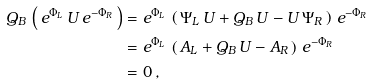<formula> <loc_0><loc_0><loc_500><loc_500>Q _ { B } \, \left ( \, e ^ { \Phi _ { L } } \, U \, e ^ { - \Phi _ { R } } \, \right ) & = e ^ { \Phi _ { L } } \, \left ( \, \Psi _ { L } \, U + Q _ { B } \, U - U \, \Psi _ { R } \, \right ) \, e ^ { - \Phi _ { R } } \\ & = e ^ { \Phi _ { L } } \, \left ( \, A _ { L } + Q _ { B } \, U - A _ { R } \, \right ) \, e ^ { - \Phi _ { R } } \\ & = 0 \, ,</formula> 